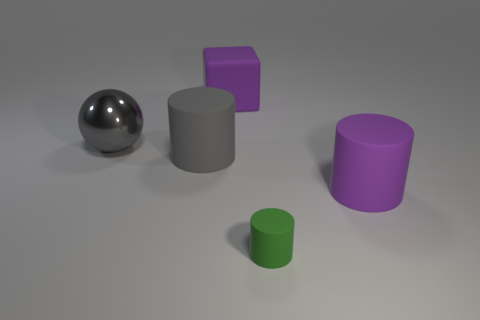Which object appears to be the shiniest in this arrangement? The shiniest object depicted in the image is the silver sphere, reflecting the most light and therefore having the most pronounced highlights. 